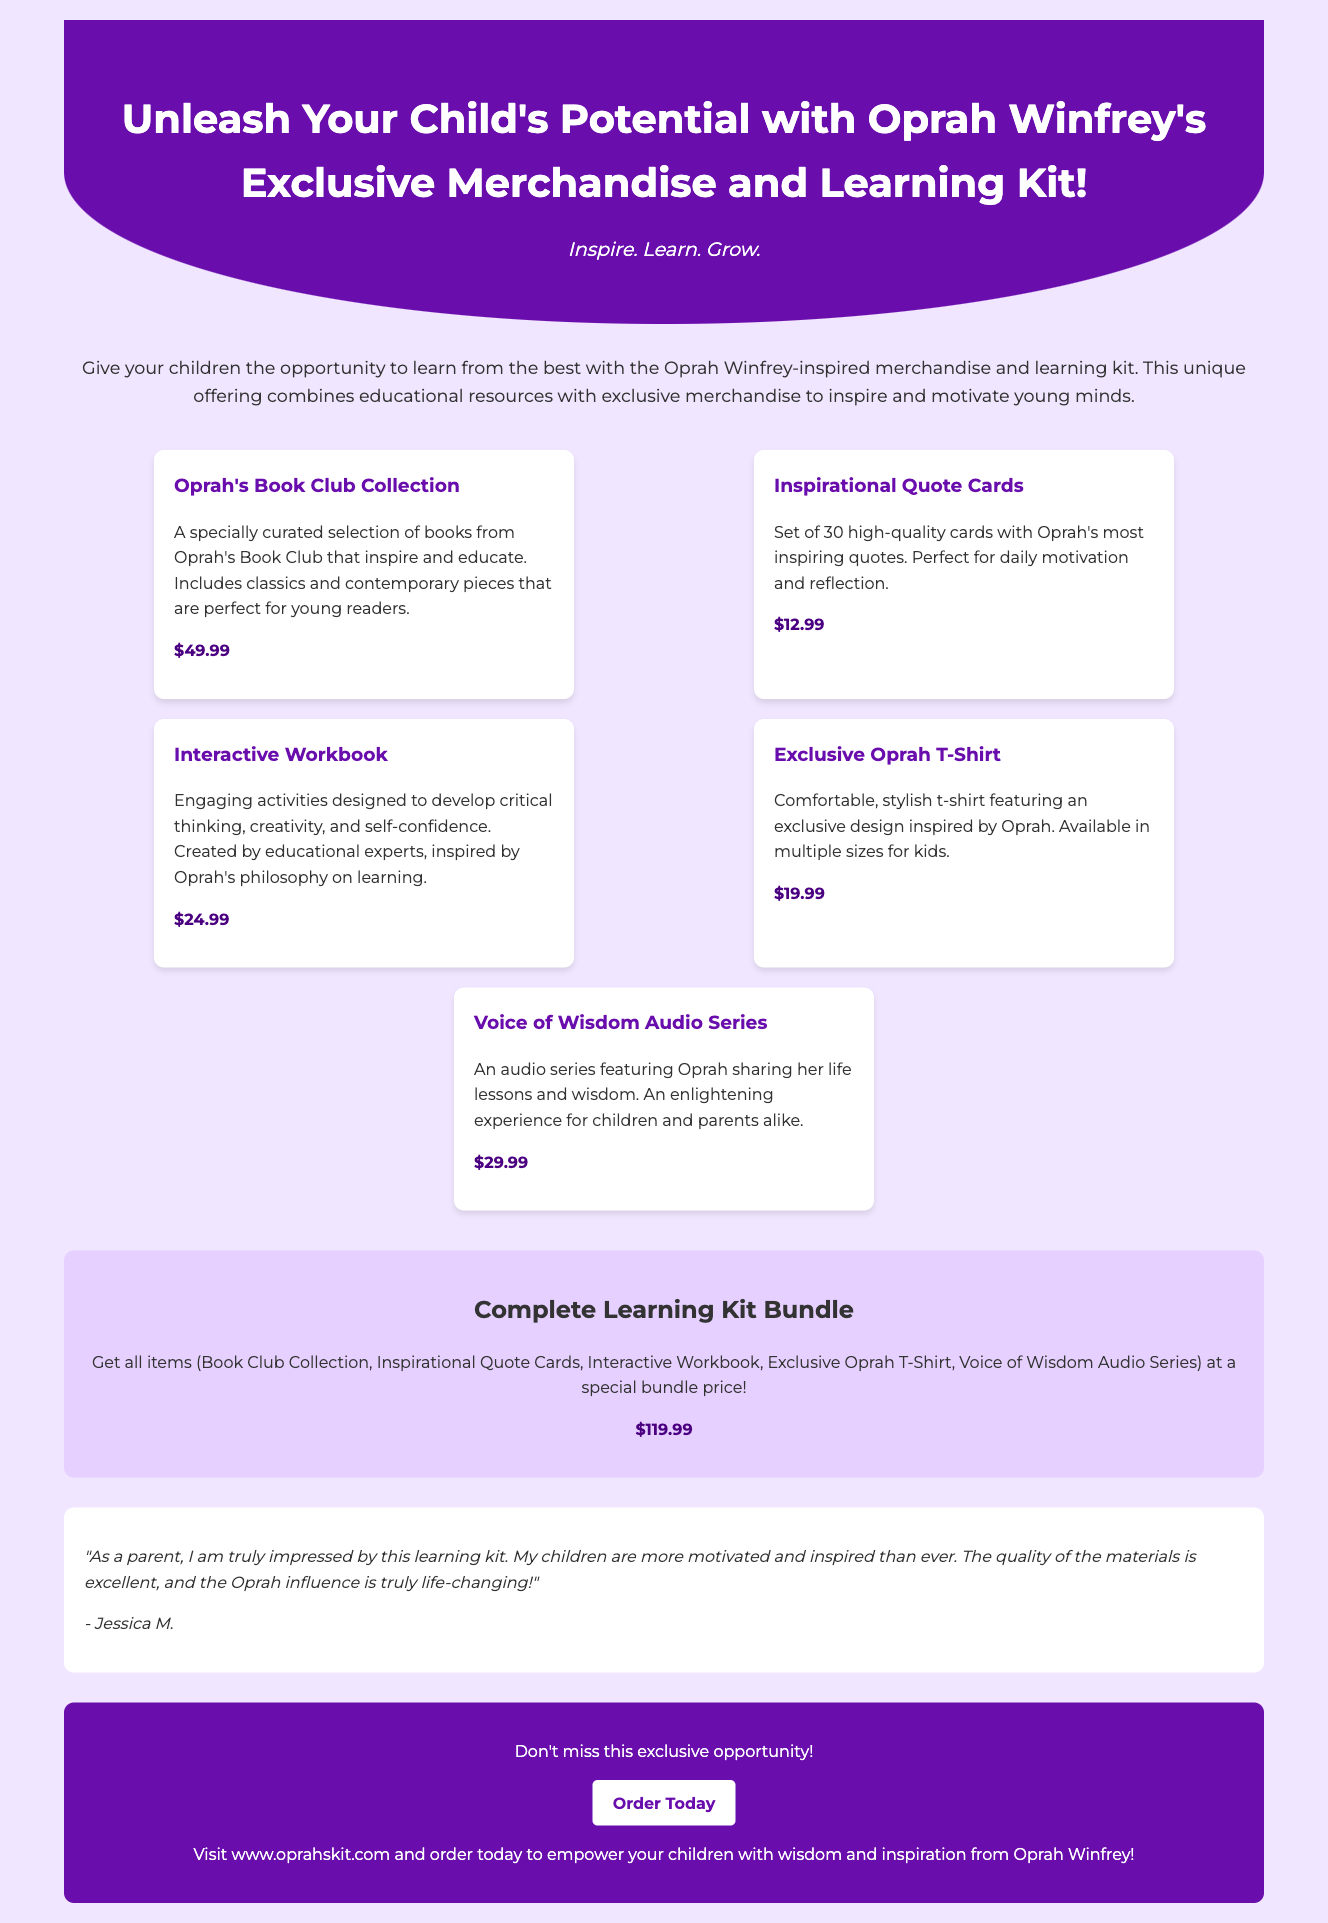What is the tagline for the advertisement? The tagline is prominently displayed under the header, capturing the essence of the advertisement's message.
Answer: Inspire. Learn. Grow What is included in the Exclusive Oprah T-Shirt? The description of the t-shirt specifies that it features an exclusive design inspired by Oprah, highlighting its appeal.
Answer: Exclusive design inspired by Oprah What is the price of the Interactive Workbook? The document lists the price for each product, allowing for easy identification of individual costs.
Answer: $24.99 What type of products are featured in the Learning Kit? The kit includes a variety of educational resources and merchandise, showcasing its comprehensive nature.
Answer: Educational resources and merchandise What is the total price of the Complete Learning Kit Bundle? The advertisement summarizes the bundle price, providing an attractive offer for buyers.
Answer: $119.99 How many Inspirational Quote Cards are included? The number of cards is stated clearly in the product description, indicating its value.
Answer: 30 What is the main benefit of the Voice of Wisdom Audio Series? The audio series is designed to share Oprah's life lessons and wisdom, enhancing the learning experience for families.
Answer: Life lessons and wisdom Who is the testimonial from? The testimonial in the document offers insight into customer satisfaction and identifies the reviewer, adding credibility.
Answer: Jessica M 